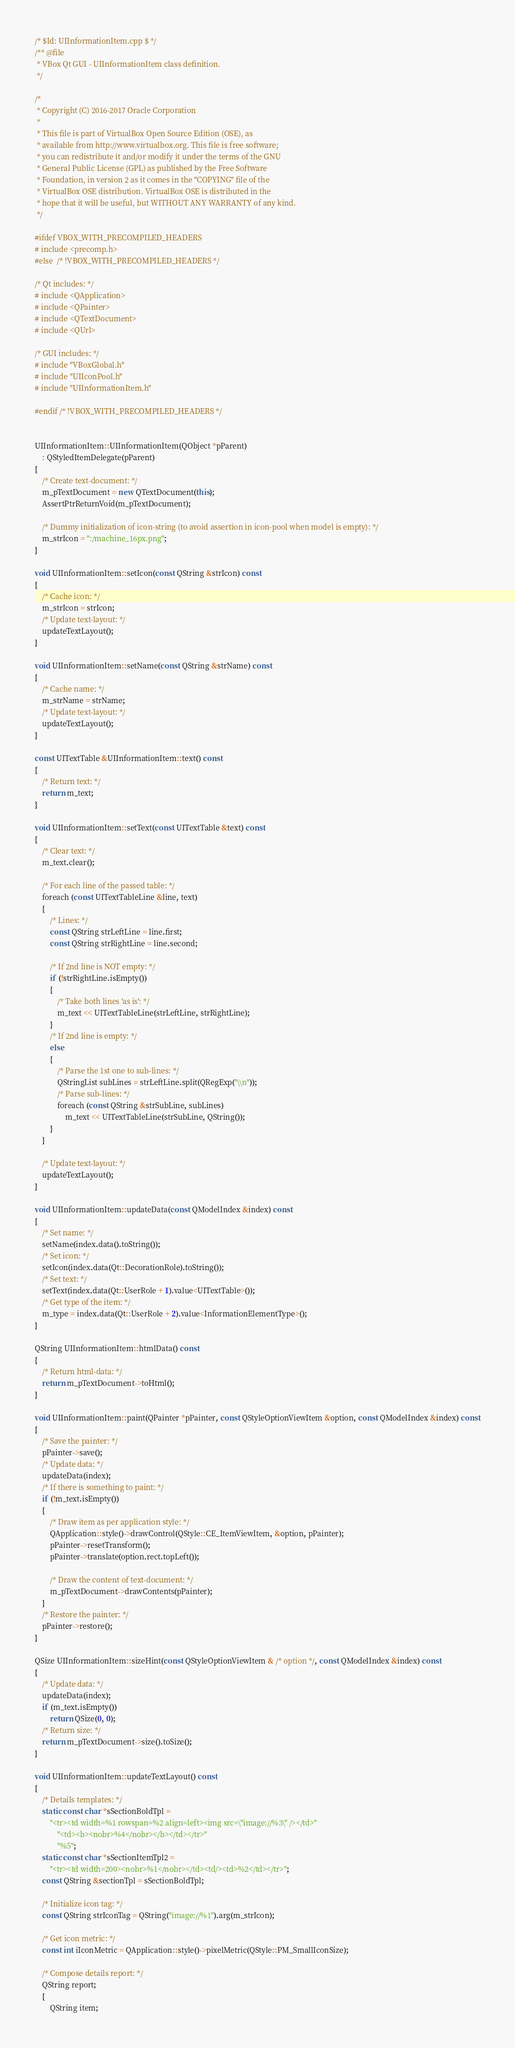Convert code to text. <code><loc_0><loc_0><loc_500><loc_500><_C++_>/* $Id: UIInformationItem.cpp $ */
/** @file
 * VBox Qt GUI - UIInformationItem class definition.
 */

/*
 * Copyright (C) 2016-2017 Oracle Corporation
 *
 * This file is part of VirtualBox Open Source Edition (OSE), as
 * available from http://www.virtualbox.org. This file is free software;
 * you can redistribute it and/or modify it under the terms of the GNU
 * General Public License (GPL) as published by the Free Software
 * Foundation, in version 2 as it comes in the "COPYING" file of the
 * VirtualBox OSE distribution. VirtualBox OSE is distributed in the
 * hope that it will be useful, but WITHOUT ANY WARRANTY of any kind.
 */

#ifdef VBOX_WITH_PRECOMPILED_HEADERS
# include <precomp.h>
#else  /* !VBOX_WITH_PRECOMPILED_HEADERS */

/* Qt includes: */
# include <QApplication>
# include <QPainter>
# include <QTextDocument>
# include <QUrl>

/* GUI includes: */
# include "VBoxGlobal.h"
# include "UIIconPool.h"
# include "UIInformationItem.h"

#endif /* !VBOX_WITH_PRECOMPILED_HEADERS */


UIInformationItem::UIInformationItem(QObject *pParent)
    : QStyledItemDelegate(pParent)
{
    /* Create text-document: */
    m_pTextDocument = new QTextDocument(this);
    AssertPtrReturnVoid(m_pTextDocument);

    /* Dummy initialization of icon-string (to avoid assertion in icon-pool when model is empty): */
    m_strIcon = ":/machine_16px.png";
}

void UIInformationItem::setIcon(const QString &strIcon) const
{
    /* Cache icon: */
    m_strIcon = strIcon;
    /* Update text-layout: */
    updateTextLayout();
}

void UIInformationItem::setName(const QString &strName) const
{
    /* Cache name: */
    m_strName = strName;
    /* Update text-layout: */
    updateTextLayout();
}

const UITextTable &UIInformationItem::text() const
{
    /* Return text: */
    return m_text;
}

void UIInformationItem::setText(const UITextTable &text) const
{
    /* Clear text: */
    m_text.clear();

    /* For each line of the passed table: */
    foreach (const UITextTableLine &line, text)
    {
        /* Lines: */
        const QString strLeftLine = line.first;
        const QString strRightLine = line.second;

        /* If 2nd line is NOT empty: */
        if (!strRightLine.isEmpty())
        {
            /* Take both lines 'as is': */
            m_text << UITextTableLine(strLeftLine, strRightLine);
        }
        /* If 2nd line is empty: */
        else
        {
            /* Parse the 1st one to sub-lines: */
            QStringList subLines = strLeftLine.split(QRegExp("\\n"));
            /* Parse sub-lines: */
            foreach (const QString &strSubLine, subLines)
                m_text << UITextTableLine(strSubLine, QString());
        }
    }

    /* Update text-layout: */
    updateTextLayout();
}

void UIInformationItem::updateData(const QModelIndex &index) const
{
    /* Set name: */
    setName(index.data().toString());
    /* Set icon: */
    setIcon(index.data(Qt::DecorationRole).toString());
    /* Set text: */
    setText(index.data(Qt::UserRole + 1).value<UITextTable>());
    /* Get type of the item: */
    m_type = index.data(Qt::UserRole + 2).value<InformationElementType>();
}

QString UIInformationItem::htmlData() const
{
    /* Return html-data: */
    return m_pTextDocument->toHtml();
}

void UIInformationItem::paint(QPainter *pPainter, const QStyleOptionViewItem &option, const QModelIndex &index) const
{
    /* Save the painter: */
    pPainter->save();
    /* Update data: */
    updateData(index);
    /* If there is something to paint: */
    if (!m_text.isEmpty())
    {
        /* Draw item as per application style: */
        QApplication::style()->drawControl(QStyle::CE_ItemViewItem, &option, pPainter);
        pPainter->resetTransform();
        pPainter->translate(option.rect.topLeft());

        /* Draw the content of text-document: */
        m_pTextDocument->drawContents(pPainter);
    }
    /* Restore the painter: */
    pPainter->restore();
}

QSize UIInformationItem::sizeHint(const QStyleOptionViewItem & /* option */, const QModelIndex &index) const
{
    /* Update data: */
    updateData(index);
    if (m_text.isEmpty())
        return QSize(0, 0);
    /* Return size: */
    return m_pTextDocument->size().toSize();
}

void UIInformationItem::updateTextLayout() const
{
    /* Details templates: */
    static const char *sSectionBoldTpl =
        "<tr><td width=%1 rowspan=%2 align=left><img src=\"image://%3\" /></td>"
            "<td><b><nobr>%4</nobr></b></td></tr>"
            "%5";
    static const char *sSectionItemTpl2 =
        "<tr><td width=200><nobr>%1</nobr></td><td/><td>%2</td></tr>";
    const QString &sectionTpl = sSectionBoldTpl;

    /* Initialize icon tag: */
    const QString strIconTag = QString("image://%1").arg(m_strIcon);

    /* Get icon metric: */
    const int iIconMetric = QApplication::style()->pixelMetric(QStyle::PM_SmallIconSize);

    /* Compose details report: */
    QString report;
    {
        QString item;</code> 